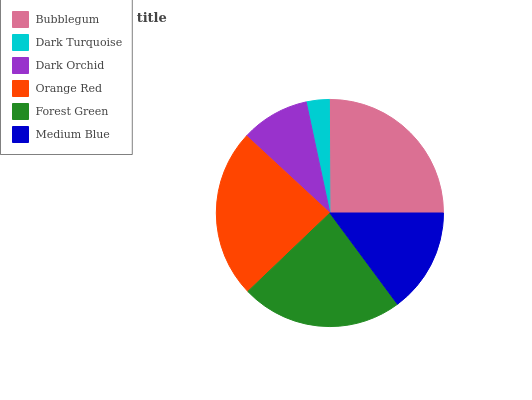Is Dark Turquoise the minimum?
Answer yes or no. Yes. Is Bubblegum the maximum?
Answer yes or no. Yes. Is Dark Orchid the minimum?
Answer yes or no. No. Is Dark Orchid the maximum?
Answer yes or no. No. Is Dark Orchid greater than Dark Turquoise?
Answer yes or no. Yes. Is Dark Turquoise less than Dark Orchid?
Answer yes or no. Yes. Is Dark Turquoise greater than Dark Orchid?
Answer yes or no. No. Is Dark Orchid less than Dark Turquoise?
Answer yes or no. No. Is Forest Green the high median?
Answer yes or no. Yes. Is Medium Blue the low median?
Answer yes or no. Yes. Is Dark Turquoise the high median?
Answer yes or no. No. Is Dark Orchid the low median?
Answer yes or no. No. 